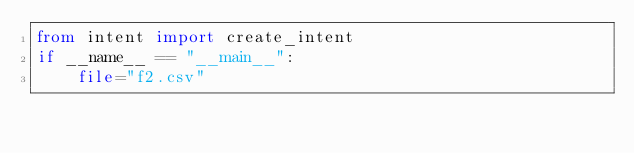Convert code to text. <code><loc_0><loc_0><loc_500><loc_500><_Python_>from intent import create_intent
if __name__ == "__main__":
    file="f2.csv"</code> 